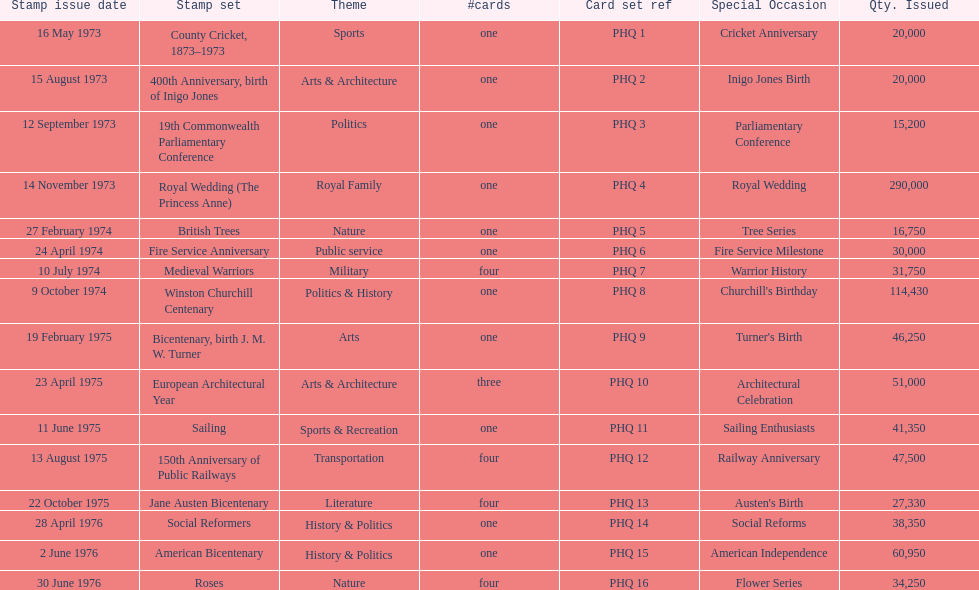Which year experienced the greatest number of stamp releases? 1973. 